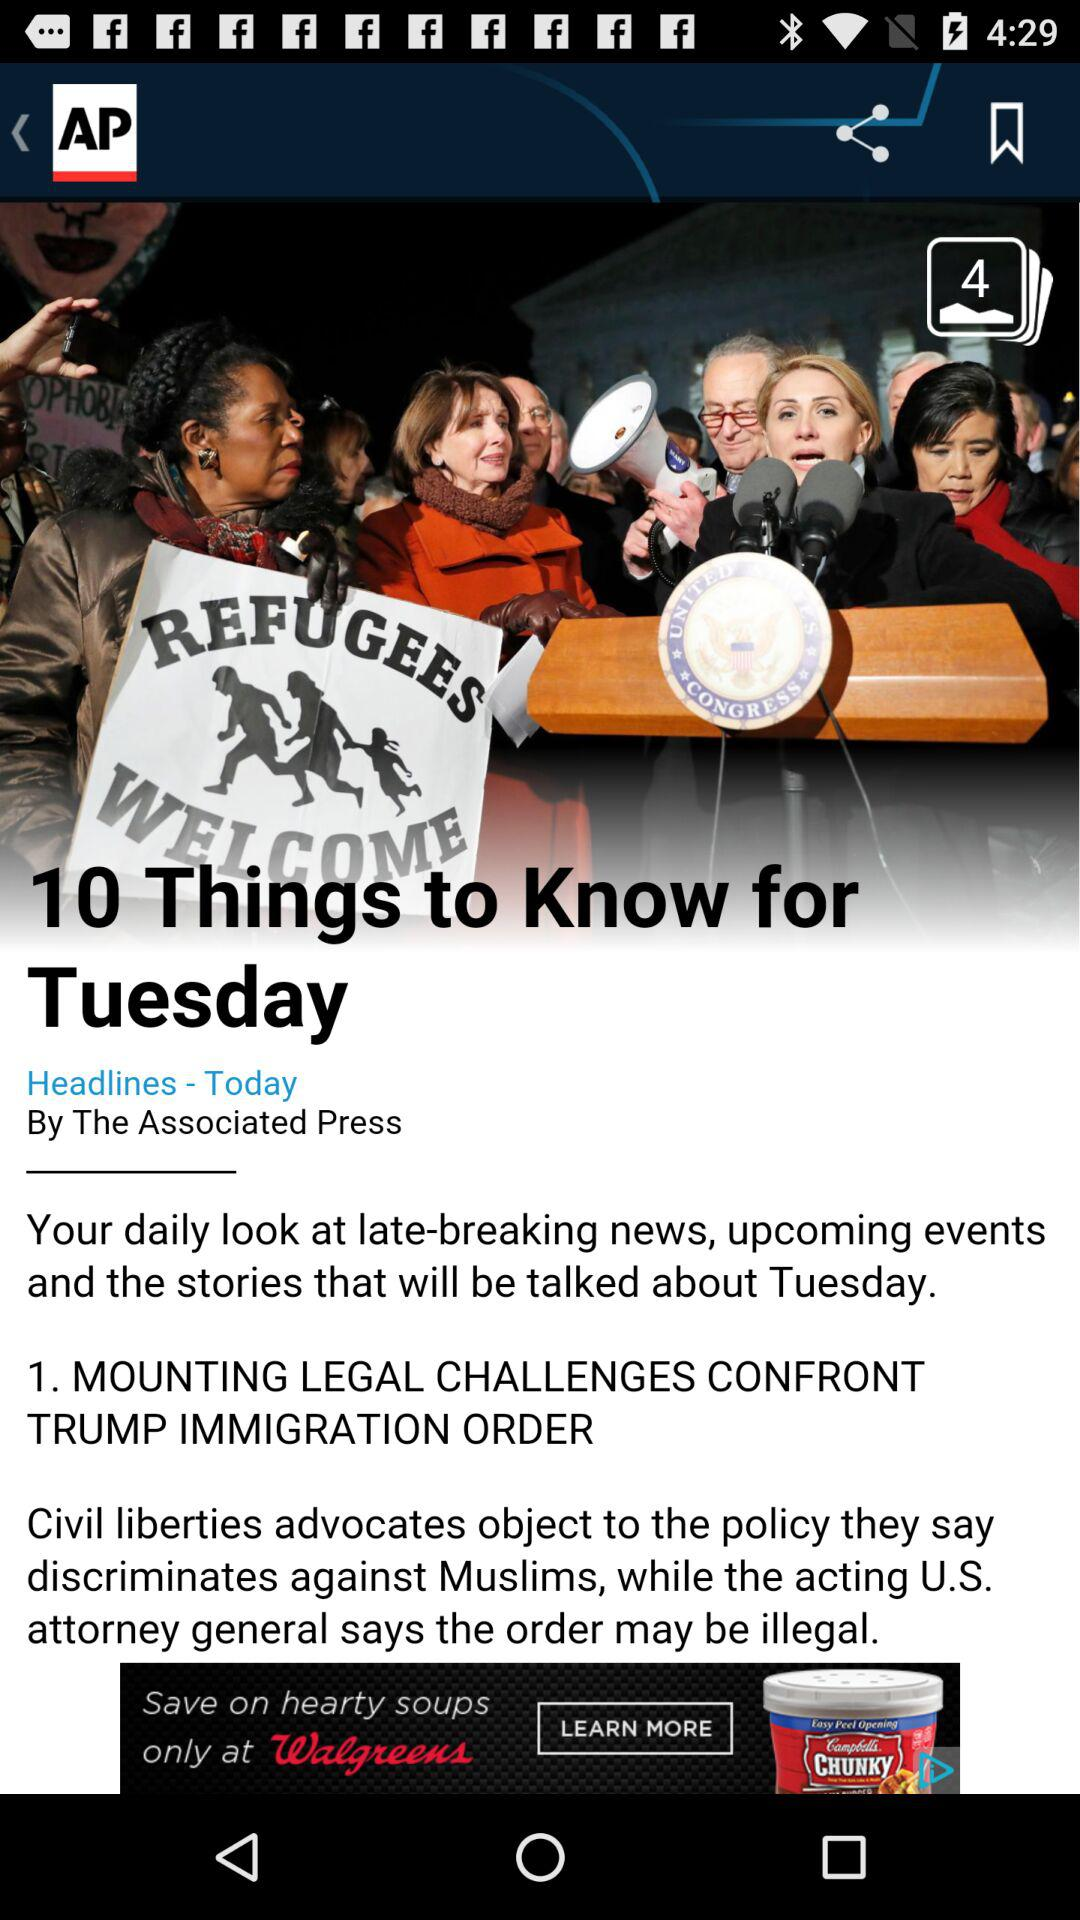How many number of photos are there? There are 4 photos. 